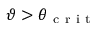Convert formula to latex. <formula><loc_0><loc_0><loc_500><loc_500>\vartheta > \theta _ { c r i t }</formula> 